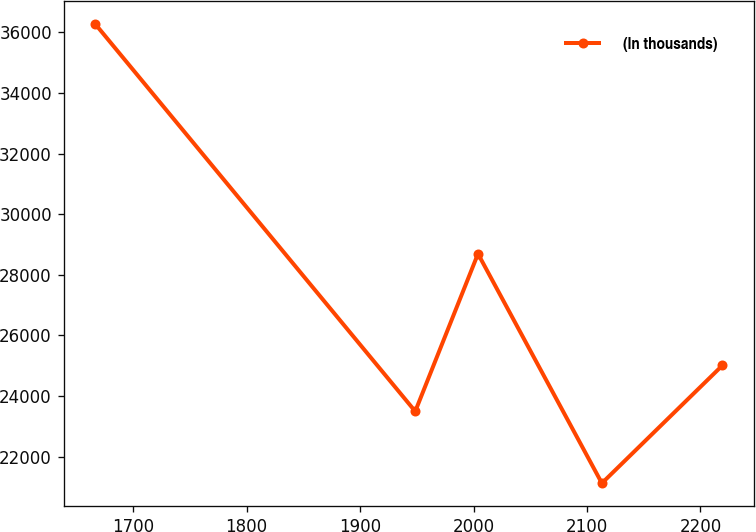Convert chart. <chart><loc_0><loc_0><loc_500><loc_500><line_chart><ecel><fcel>(In thousands)<nl><fcel>1666.24<fcel>36294.5<nl><fcel>1948.62<fcel>23493<nl><fcel>2003.94<fcel>28695.1<nl><fcel>2113.14<fcel>21121.4<nl><fcel>2219.4<fcel>25010.3<nl></chart> 